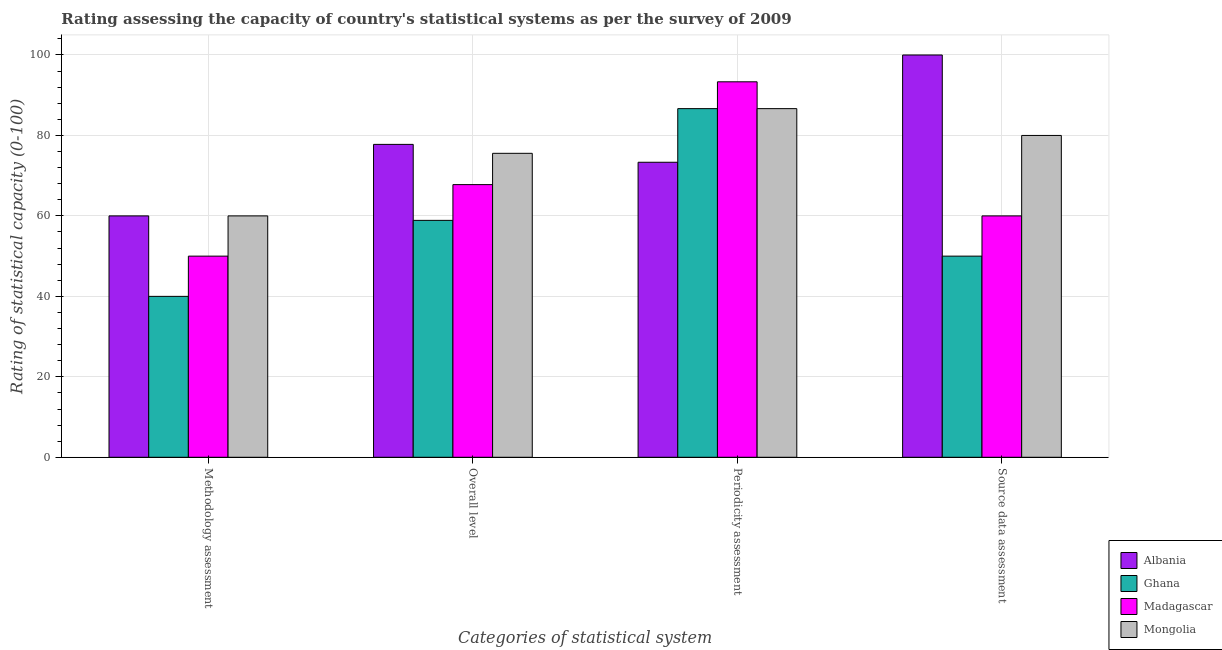How many different coloured bars are there?
Make the answer very short. 4. Are the number of bars per tick equal to the number of legend labels?
Ensure brevity in your answer.  Yes. Are the number of bars on each tick of the X-axis equal?
Offer a terse response. Yes. How many bars are there on the 3rd tick from the right?
Make the answer very short. 4. What is the label of the 2nd group of bars from the left?
Give a very brief answer. Overall level. What is the source data assessment rating in Albania?
Offer a terse response. 100. Across all countries, what is the maximum periodicity assessment rating?
Ensure brevity in your answer.  93.33. Across all countries, what is the minimum periodicity assessment rating?
Your answer should be very brief. 73.33. In which country was the methodology assessment rating maximum?
Provide a short and direct response. Albania. In which country was the overall level rating minimum?
Give a very brief answer. Ghana. What is the total methodology assessment rating in the graph?
Your answer should be compact. 210. What is the difference between the overall level rating in Albania and that in Ghana?
Your answer should be very brief. 18.89. What is the difference between the periodicity assessment rating in Madagascar and the methodology assessment rating in Mongolia?
Provide a succinct answer. 33.33. What is the difference between the periodicity assessment rating and overall level rating in Madagascar?
Provide a short and direct response. 25.56. In how many countries, is the overall level rating greater than 100 ?
Keep it short and to the point. 0. What is the ratio of the overall level rating in Mongolia to that in Ghana?
Your response must be concise. 1.28. Is the difference between the source data assessment rating in Madagascar and Albania greater than the difference between the overall level rating in Madagascar and Albania?
Keep it short and to the point. No. What is the difference between the highest and the second highest periodicity assessment rating?
Provide a short and direct response. 6.67. What is the difference between the highest and the lowest methodology assessment rating?
Your answer should be very brief. 20. Is it the case that in every country, the sum of the periodicity assessment rating and methodology assessment rating is greater than the sum of source data assessment rating and overall level rating?
Give a very brief answer. No. What does the 4th bar from the left in Overall level represents?
Provide a short and direct response. Mongolia. What does the 1st bar from the right in Overall level represents?
Your answer should be compact. Mongolia. Is it the case that in every country, the sum of the methodology assessment rating and overall level rating is greater than the periodicity assessment rating?
Offer a terse response. Yes. How many bars are there?
Your response must be concise. 16. Are the values on the major ticks of Y-axis written in scientific E-notation?
Offer a terse response. No. Does the graph contain any zero values?
Give a very brief answer. No. Where does the legend appear in the graph?
Your answer should be compact. Bottom right. What is the title of the graph?
Offer a terse response. Rating assessing the capacity of country's statistical systems as per the survey of 2009 . What is the label or title of the X-axis?
Ensure brevity in your answer.  Categories of statistical system. What is the label or title of the Y-axis?
Offer a very short reply. Rating of statistical capacity (0-100). What is the Rating of statistical capacity (0-100) in Albania in Methodology assessment?
Your response must be concise. 60. What is the Rating of statistical capacity (0-100) in Mongolia in Methodology assessment?
Keep it short and to the point. 60. What is the Rating of statistical capacity (0-100) of Albania in Overall level?
Your response must be concise. 77.78. What is the Rating of statistical capacity (0-100) of Ghana in Overall level?
Provide a short and direct response. 58.89. What is the Rating of statistical capacity (0-100) in Madagascar in Overall level?
Give a very brief answer. 67.78. What is the Rating of statistical capacity (0-100) of Mongolia in Overall level?
Provide a short and direct response. 75.56. What is the Rating of statistical capacity (0-100) in Albania in Periodicity assessment?
Offer a very short reply. 73.33. What is the Rating of statistical capacity (0-100) of Ghana in Periodicity assessment?
Offer a very short reply. 86.67. What is the Rating of statistical capacity (0-100) in Madagascar in Periodicity assessment?
Your answer should be very brief. 93.33. What is the Rating of statistical capacity (0-100) in Mongolia in Periodicity assessment?
Offer a very short reply. 86.67. What is the Rating of statistical capacity (0-100) in Albania in Source data assessment?
Provide a succinct answer. 100. What is the Rating of statistical capacity (0-100) in Madagascar in Source data assessment?
Ensure brevity in your answer.  60. Across all Categories of statistical system, what is the maximum Rating of statistical capacity (0-100) in Albania?
Keep it short and to the point. 100. Across all Categories of statistical system, what is the maximum Rating of statistical capacity (0-100) in Ghana?
Keep it short and to the point. 86.67. Across all Categories of statistical system, what is the maximum Rating of statistical capacity (0-100) in Madagascar?
Your answer should be compact. 93.33. Across all Categories of statistical system, what is the maximum Rating of statistical capacity (0-100) of Mongolia?
Keep it short and to the point. 86.67. Across all Categories of statistical system, what is the minimum Rating of statistical capacity (0-100) in Ghana?
Offer a terse response. 40. Across all Categories of statistical system, what is the minimum Rating of statistical capacity (0-100) in Madagascar?
Provide a succinct answer. 50. Across all Categories of statistical system, what is the minimum Rating of statistical capacity (0-100) in Mongolia?
Offer a terse response. 60. What is the total Rating of statistical capacity (0-100) in Albania in the graph?
Ensure brevity in your answer.  311.11. What is the total Rating of statistical capacity (0-100) in Ghana in the graph?
Provide a short and direct response. 235.56. What is the total Rating of statistical capacity (0-100) of Madagascar in the graph?
Provide a succinct answer. 271.11. What is the total Rating of statistical capacity (0-100) in Mongolia in the graph?
Provide a succinct answer. 302.22. What is the difference between the Rating of statistical capacity (0-100) of Albania in Methodology assessment and that in Overall level?
Offer a very short reply. -17.78. What is the difference between the Rating of statistical capacity (0-100) of Ghana in Methodology assessment and that in Overall level?
Offer a very short reply. -18.89. What is the difference between the Rating of statistical capacity (0-100) in Madagascar in Methodology assessment and that in Overall level?
Provide a succinct answer. -17.78. What is the difference between the Rating of statistical capacity (0-100) in Mongolia in Methodology assessment and that in Overall level?
Your answer should be compact. -15.56. What is the difference between the Rating of statistical capacity (0-100) of Albania in Methodology assessment and that in Periodicity assessment?
Make the answer very short. -13.33. What is the difference between the Rating of statistical capacity (0-100) of Ghana in Methodology assessment and that in Periodicity assessment?
Your answer should be compact. -46.67. What is the difference between the Rating of statistical capacity (0-100) of Madagascar in Methodology assessment and that in Periodicity assessment?
Your answer should be compact. -43.33. What is the difference between the Rating of statistical capacity (0-100) of Mongolia in Methodology assessment and that in Periodicity assessment?
Your answer should be compact. -26.67. What is the difference between the Rating of statistical capacity (0-100) of Albania in Methodology assessment and that in Source data assessment?
Your answer should be very brief. -40. What is the difference between the Rating of statistical capacity (0-100) in Ghana in Methodology assessment and that in Source data assessment?
Your answer should be very brief. -10. What is the difference between the Rating of statistical capacity (0-100) of Albania in Overall level and that in Periodicity assessment?
Give a very brief answer. 4.44. What is the difference between the Rating of statistical capacity (0-100) in Ghana in Overall level and that in Periodicity assessment?
Keep it short and to the point. -27.78. What is the difference between the Rating of statistical capacity (0-100) in Madagascar in Overall level and that in Periodicity assessment?
Your response must be concise. -25.56. What is the difference between the Rating of statistical capacity (0-100) in Mongolia in Overall level and that in Periodicity assessment?
Your answer should be very brief. -11.11. What is the difference between the Rating of statistical capacity (0-100) in Albania in Overall level and that in Source data assessment?
Offer a terse response. -22.22. What is the difference between the Rating of statistical capacity (0-100) of Ghana in Overall level and that in Source data assessment?
Provide a succinct answer. 8.89. What is the difference between the Rating of statistical capacity (0-100) in Madagascar in Overall level and that in Source data assessment?
Make the answer very short. 7.78. What is the difference between the Rating of statistical capacity (0-100) of Mongolia in Overall level and that in Source data assessment?
Offer a very short reply. -4.44. What is the difference between the Rating of statistical capacity (0-100) of Albania in Periodicity assessment and that in Source data assessment?
Ensure brevity in your answer.  -26.67. What is the difference between the Rating of statistical capacity (0-100) of Ghana in Periodicity assessment and that in Source data assessment?
Make the answer very short. 36.67. What is the difference between the Rating of statistical capacity (0-100) in Madagascar in Periodicity assessment and that in Source data assessment?
Your answer should be very brief. 33.33. What is the difference between the Rating of statistical capacity (0-100) in Mongolia in Periodicity assessment and that in Source data assessment?
Offer a terse response. 6.67. What is the difference between the Rating of statistical capacity (0-100) of Albania in Methodology assessment and the Rating of statistical capacity (0-100) of Madagascar in Overall level?
Your answer should be very brief. -7.78. What is the difference between the Rating of statistical capacity (0-100) of Albania in Methodology assessment and the Rating of statistical capacity (0-100) of Mongolia in Overall level?
Give a very brief answer. -15.56. What is the difference between the Rating of statistical capacity (0-100) in Ghana in Methodology assessment and the Rating of statistical capacity (0-100) in Madagascar in Overall level?
Offer a terse response. -27.78. What is the difference between the Rating of statistical capacity (0-100) in Ghana in Methodology assessment and the Rating of statistical capacity (0-100) in Mongolia in Overall level?
Make the answer very short. -35.56. What is the difference between the Rating of statistical capacity (0-100) in Madagascar in Methodology assessment and the Rating of statistical capacity (0-100) in Mongolia in Overall level?
Offer a terse response. -25.56. What is the difference between the Rating of statistical capacity (0-100) in Albania in Methodology assessment and the Rating of statistical capacity (0-100) in Ghana in Periodicity assessment?
Offer a terse response. -26.67. What is the difference between the Rating of statistical capacity (0-100) of Albania in Methodology assessment and the Rating of statistical capacity (0-100) of Madagascar in Periodicity assessment?
Offer a very short reply. -33.33. What is the difference between the Rating of statistical capacity (0-100) of Albania in Methodology assessment and the Rating of statistical capacity (0-100) of Mongolia in Periodicity assessment?
Ensure brevity in your answer.  -26.67. What is the difference between the Rating of statistical capacity (0-100) in Ghana in Methodology assessment and the Rating of statistical capacity (0-100) in Madagascar in Periodicity assessment?
Offer a terse response. -53.33. What is the difference between the Rating of statistical capacity (0-100) in Ghana in Methodology assessment and the Rating of statistical capacity (0-100) in Mongolia in Periodicity assessment?
Keep it short and to the point. -46.67. What is the difference between the Rating of statistical capacity (0-100) in Madagascar in Methodology assessment and the Rating of statistical capacity (0-100) in Mongolia in Periodicity assessment?
Ensure brevity in your answer.  -36.67. What is the difference between the Rating of statistical capacity (0-100) of Albania in Methodology assessment and the Rating of statistical capacity (0-100) of Ghana in Source data assessment?
Offer a very short reply. 10. What is the difference between the Rating of statistical capacity (0-100) of Albania in Methodology assessment and the Rating of statistical capacity (0-100) of Mongolia in Source data assessment?
Your response must be concise. -20. What is the difference between the Rating of statistical capacity (0-100) of Ghana in Methodology assessment and the Rating of statistical capacity (0-100) of Madagascar in Source data assessment?
Provide a succinct answer. -20. What is the difference between the Rating of statistical capacity (0-100) of Ghana in Methodology assessment and the Rating of statistical capacity (0-100) of Mongolia in Source data assessment?
Provide a succinct answer. -40. What is the difference between the Rating of statistical capacity (0-100) in Albania in Overall level and the Rating of statistical capacity (0-100) in Ghana in Periodicity assessment?
Your answer should be very brief. -8.89. What is the difference between the Rating of statistical capacity (0-100) in Albania in Overall level and the Rating of statistical capacity (0-100) in Madagascar in Periodicity assessment?
Keep it short and to the point. -15.56. What is the difference between the Rating of statistical capacity (0-100) in Albania in Overall level and the Rating of statistical capacity (0-100) in Mongolia in Periodicity assessment?
Provide a succinct answer. -8.89. What is the difference between the Rating of statistical capacity (0-100) in Ghana in Overall level and the Rating of statistical capacity (0-100) in Madagascar in Periodicity assessment?
Ensure brevity in your answer.  -34.44. What is the difference between the Rating of statistical capacity (0-100) in Ghana in Overall level and the Rating of statistical capacity (0-100) in Mongolia in Periodicity assessment?
Your answer should be very brief. -27.78. What is the difference between the Rating of statistical capacity (0-100) in Madagascar in Overall level and the Rating of statistical capacity (0-100) in Mongolia in Periodicity assessment?
Offer a very short reply. -18.89. What is the difference between the Rating of statistical capacity (0-100) of Albania in Overall level and the Rating of statistical capacity (0-100) of Ghana in Source data assessment?
Your answer should be compact. 27.78. What is the difference between the Rating of statistical capacity (0-100) of Albania in Overall level and the Rating of statistical capacity (0-100) of Madagascar in Source data assessment?
Keep it short and to the point. 17.78. What is the difference between the Rating of statistical capacity (0-100) in Albania in Overall level and the Rating of statistical capacity (0-100) in Mongolia in Source data assessment?
Give a very brief answer. -2.22. What is the difference between the Rating of statistical capacity (0-100) of Ghana in Overall level and the Rating of statistical capacity (0-100) of Madagascar in Source data assessment?
Keep it short and to the point. -1.11. What is the difference between the Rating of statistical capacity (0-100) of Ghana in Overall level and the Rating of statistical capacity (0-100) of Mongolia in Source data assessment?
Offer a terse response. -21.11. What is the difference between the Rating of statistical capacity (0-100) of Madagascar in Overall level and the Rating of statistical capacity (0-100) of Mongolia in Source data assessment?
Keep it short and to the point. -12.22. What is the difference between the Rating of statistical capacity (0-100) of Albania in Periodicity assessment and the Rating of statistical capacity (0-100) of Ghana in Source data assessment?
Your answer should be very brief. 23.33. What is the difference between the Rating of statistical capacity (0-100) of Albania in Periodicity assessment and the Rating of statistical capacity (0-100) of Madagascar in Source data assessment?
Give a very brief answer. 13.33. What is the difference between the Rating of statistical capacity (0-100) of Albania in Periodicity assessment and the Rating of statistical capacity (0-100) of Mongolia in Source data assessment?
Your answer should be compact. -6.67. What is the difference between the Rating of statistical capacity (0-100) of Ghana in Periodicity assessment and the Rating of statistical capacity (0-100) of Madagascar in Source data assessment?
Provide a short and direct response. 26.67. What is the difference between the Rating of statistical capacity (0-100) of Ghana in Periodicity assessment and the Rating of statistical capacity (0-100) of Mongolia in Source data assessment?
Provide a succinct answer. 6.67. What is the difference between the Rating of statistical capacity (0-100) in Madagascar in Periodicity assessment and the Rating of statistical capacity (0-100) in Mongolia in Source data assessment?
Give a very brief answer. 13.33. What is the average Rating of statistical capacity (0-100) of Albania per Categories of statistical system?
Your response must be concise. 77.78. What is the average Rating of statistical capacity (0-100) of Ghana per Categories of statistical system?
Offer a very short reply. 58.89. What is the average Rating of statistical capacity (0-100) in Madagascar per Categories of statistical system?
Offer a very short reply. 67.78. What is the average Rating of statistical capacity (0-100) of Mongolia per Categories of statistical system?
Offer a terse response. 75.56. What is the difference between the Rating of statistical capacity (0-100) in Albania and Rating of statistical capacity (0-100) in Mongolia in Methodology assessment?
Ensure brevity in your answer.  0. What is the difference between the Rating of statistical capacity (0-100) in Ghana and Rating of statistical capacity (0-100) in Madagascar in Methodology assessment?
Provide a short and direct response. -10. What is the difference between the Rating of statistical capacity (0-100) in Ghana and Rating of statistical capacity (0-100) in Mongolia in Methodology assessment?
Keep it short and to the point. -20. What is the difference between the Rating of statistical capacity (0-100) in Albania and Rating of statistical capacity (0-100) in Ghana in Overall level?
Provide a short and direct response. 18.89. What is the difference between the Rating of statistical capacity (0-100) in Albania and Rating of statistical capacity (0-100) in Mongolia in Overall level?
Offer a terse response. 2.22. What is the difference between the Rating of statistical capacity (0-100) in Ghana and Rating of statistical capacity (0-100) in Madagascar in Overall level?
Your answer should be compact. -8.89. What is the difference between the Rating of statistical capacity (0-100) in Ghana and Rating of statistical capacity (0-100) in Mongolia in Overall level?
Ensure brevity in your answer.  -16.67. What is the difference between the Rating of statistical capacity (0-100) in Madagascar and Rating of statistical capacity (0-100) in Mongolia in Overall level?
Offer a terse response. -7.78. What is the difference between the Rating of statistical capacity (0-100) of Albania and Rating of statistical capacity (0-100) of Ghana in Periodicity assessment?
Offer a terse response. -13.33. What is the difference between the Rating of statistical capacity (0-100) of Albania and Rating of statistical capacity (0-100) of Mongolia in Periodicity assessment?
Offer a terse response. -13.33. What is the difference between the Rating of statistical capacity (0-100) in Ghana and Rating of statistical capacity (0-100) in Madagascar in Periodicity assessment?
Make the answer very short. -6.67. What is the difference between the Rating of statistical capacity (0-100) in Madagascar and Rating of statistical capacity (0-100) in Mongolia in Periodicity assessment?
Offer a very short reply. 6.67. What is the difference between the Rating of statistical capacity (0-100) in Albania and Rating of statistical capacity (0-100) in Ghana in Source data assessment?
Your answer should be very brief. 50. What is the difference between the Rating of statistical capacity (0-100) of Albania and Rating of statistical capacity (0-100) of Madagascar in Source data assessment?
Give a very brief answer. 40. What is the difference between the Rating of statistical capacity (0-100) of Madagascar and Rating of statistical capacity (0-100) of Mongolia in Source data assessment?
Your answer should be compact. -20. What is the ratio of the Rating of statistical capacity (0-100) of Albania in Methodology assessment to that in Overall level?
Provide a short and direct response. 0.77. What is the ratio of the Rating of statistical capacity (0-100) in Ghana in Methodology assessment to that in Overall level?
Give a very brief answer. 0.68. What is the ratio of the Rating of statistical capacity (0-100) of Madagascar in Methodology assessment to that in Overall level?
Offer a terse response. 0.74. What is the ratio of the Rating of statistical capacity (0-100) in Mongolia in Methodology assessment to that in Overall level?
Your answer should be compact. 0.79. What is the ratio of the Rating of statistical capacity (0-100) in Albania in Methodology assessment to that in Periodicity assessment?
Your answer should be very brief. 0.82. What is the ratio of the Rating of statistical capacity (0-100) in Ghana in Methodology assessment to that in Periodicity assessment?
Make the answer very short. 0.46. What is the ratio of the Rating of statistical capacity (0-100) in Madagascar in Methodology assessment to that in Periodicity assessment?
Ensure brevity in your answer.  0.54. What is the ratio of the Rating of statistical capacity (0-100) in Mongolia in Methodology assessment to that in Periodicity assessment?
Your answer should be compact. 0.69. What is the ratio of the Rating of statistical capacity (0-100) of Ghana in Methodology assessment to that in Source data assessment?
Offer a very short reply. 0.8. What is the ratio of the Rating of statistical capacity (0-100) in Mongolia in Methodology assessment to that in Source data assessment?
Offer a terse response. 0.75. What is the ratio of the Rating of statistical capacity (0-100) of Albania in Overall level to that in Periodicity assessment?
Ensure brevity in your answer.  1.06. What is the ratio of the Rating of statistical capacity (0-100) of Ghana in Overall level to that in Periodicity assessment?
Give a very brief answer. 0.68. What is the ratio of the Rating of statistical capacity (0-100) of Madagascar in Overall level to that in Periodicity assessment?
Give a very brief answer. 0.73. What is the ratio of the Rating of statistical capacity (0-100) in Mongolia in Overall level to that in Periodicity assessment?
Your answer should be compact. 0.87. What is the ratio of the Rating of statistical capacity (0-100) in Ghana in Overall level to that in Source data assessment?
Offer a very short reply. 1.18. What is the ratio of the Rating of statistical capacity (0-100) in Madagascar in Overall level to that in Source data assessment?
Offer a very short reply. 1.13. What is the ratio of the Rating of statistical capacity (0-100) of Mongolia in Overall level to that in Source data assessment?
Keep it short and to the point. 0.94. What is the ratio of the Rating of statistical capacity (0-100) of Albania in Periodicity assessment to that in Source data assessment?
Provide a succinct answer. 0.73. What is the ratio of the Rating of statistical capacity (0-100) in Ghana in Periodicity assessment to that in Source data assessment?
Ensure brevity in your answer.  1.73. What is the ratio of the Rating of statistical capacity (0-100) of Madagascar in Periodicity assessment to that in Source data assessment?
Ensure brevity in your answer.  1.56. What is the ratio of the Rating of statistical capacity (0-100) of Mongolia in Periodicity assessment to that in Source data assessment?
Your answer should be very brief. 1.08. What is the difference between the highest and the second highest Rating of statistical capacity (0-100) of Albania?
Your response must be concise. 22.22. What is the difference between the highest and the second highest Rating of statistical capacity (0-100) of Ghana?
Provide a succinct answer. 27.78. What is the difference between the highest and the second highest Rating of statistical capacity (0-100) of Madagascar?
Provide a short and direct response. 25.56. What is the difference between the highest and the lowest Rating of statistical capacity (0-100) of Ghana?
Give a very brief answer. 46.67. What is the difference between the highest and the lowest Rating of statistical capacity (0-100) of Madagascar?
Offer a terse response. 43.33. What is the difference between the highest and the lowest Rating of statistical capacity (0-100) of Mongolia?
Offer a terse response. 26.67. 